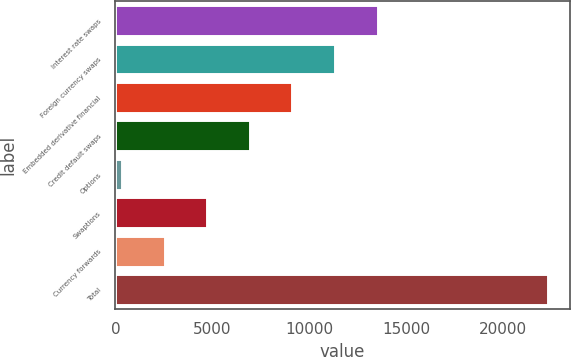Convert chart. <chart><loc_0><loc_0><loc_500><loc_500><bar_chart><fcel>Interest rate swaps<fcel>Foreign currency swaps<fcel>Embedded derivative financial<fcel>Credit default swaps<fcel>Options<fcel>Swaptions<fcel>Currency forwards<fcel>Total<nl><fcel>13533.1<fcel>11333.4<fcel>9133.72<fcel>6934.04<fcel>335<fcel>4734.36<fcel>2534.68<fcel>22331.8<nl></chart> 